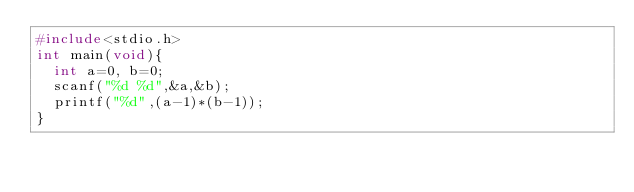<code> <loc_0><loc_0><loc_500><loc_500><_C_>#include<stdio.h>
int main(void){
  int a=0, b=0;
  scanf("%d %d",&a,&b);
  printf("%d",(a-1)*(b-1));
}
</code> 